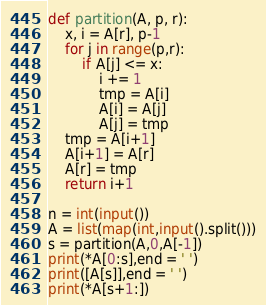Convert code to text. <code><loc_0><loc_0><loc_500><loc_500><_Python_>def partition(A, p, r):
    x, i = A[r], p-1
    for j in range(p,r):
        if A[j] <= x:
            i += 1
            tmp = A[i]
            A[i] = A[j]
            A[j] = tmp
    tmp = A[i+1]
    A[i+1] = A[r]
    A[r] = tmp
    return i+1

n = int(input())
A = list(map(int,input().split()))
s = partition(A,0,A[-1])
print(*A[0:s],end = ' ')
print([A[s]],end = ' ')
print(*A[s+1:])</code> 